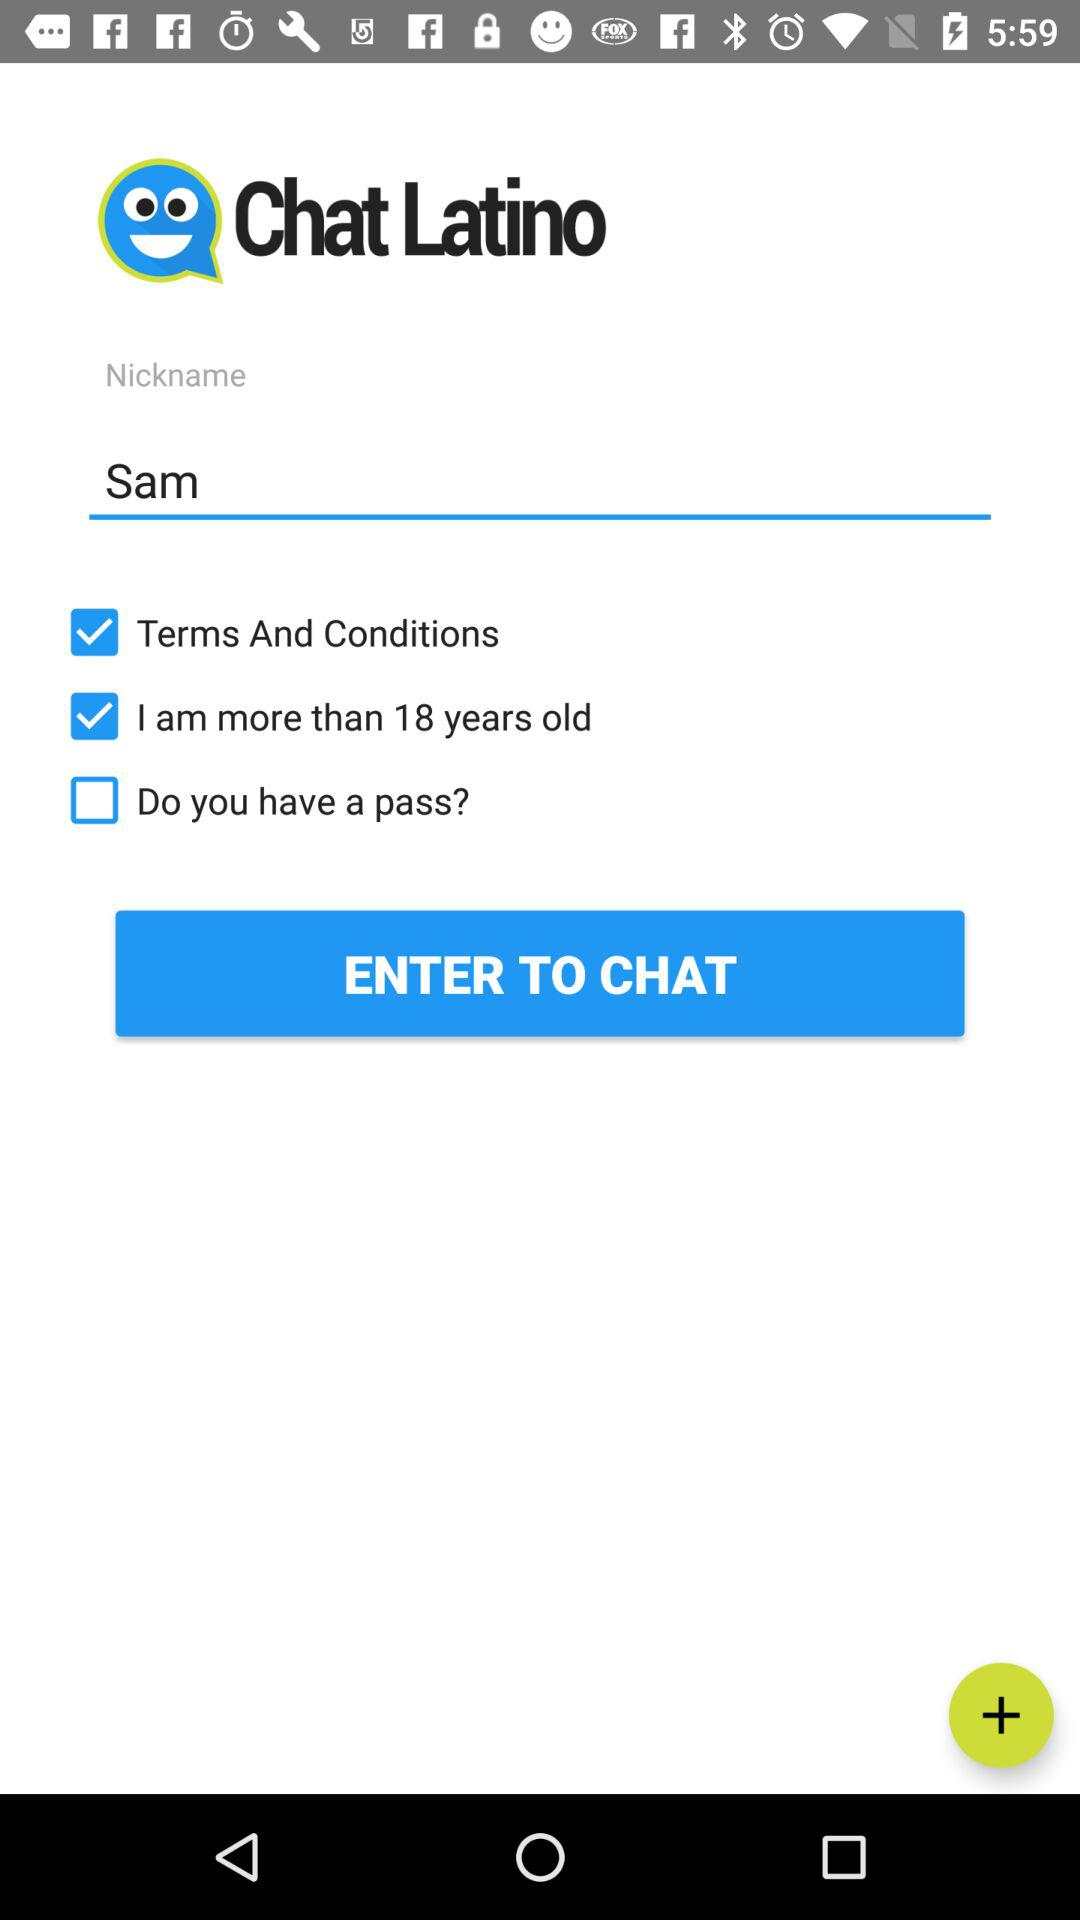Which options are selected? The selected options are "Terms And Conditions" and "I am more than 18 years old". 